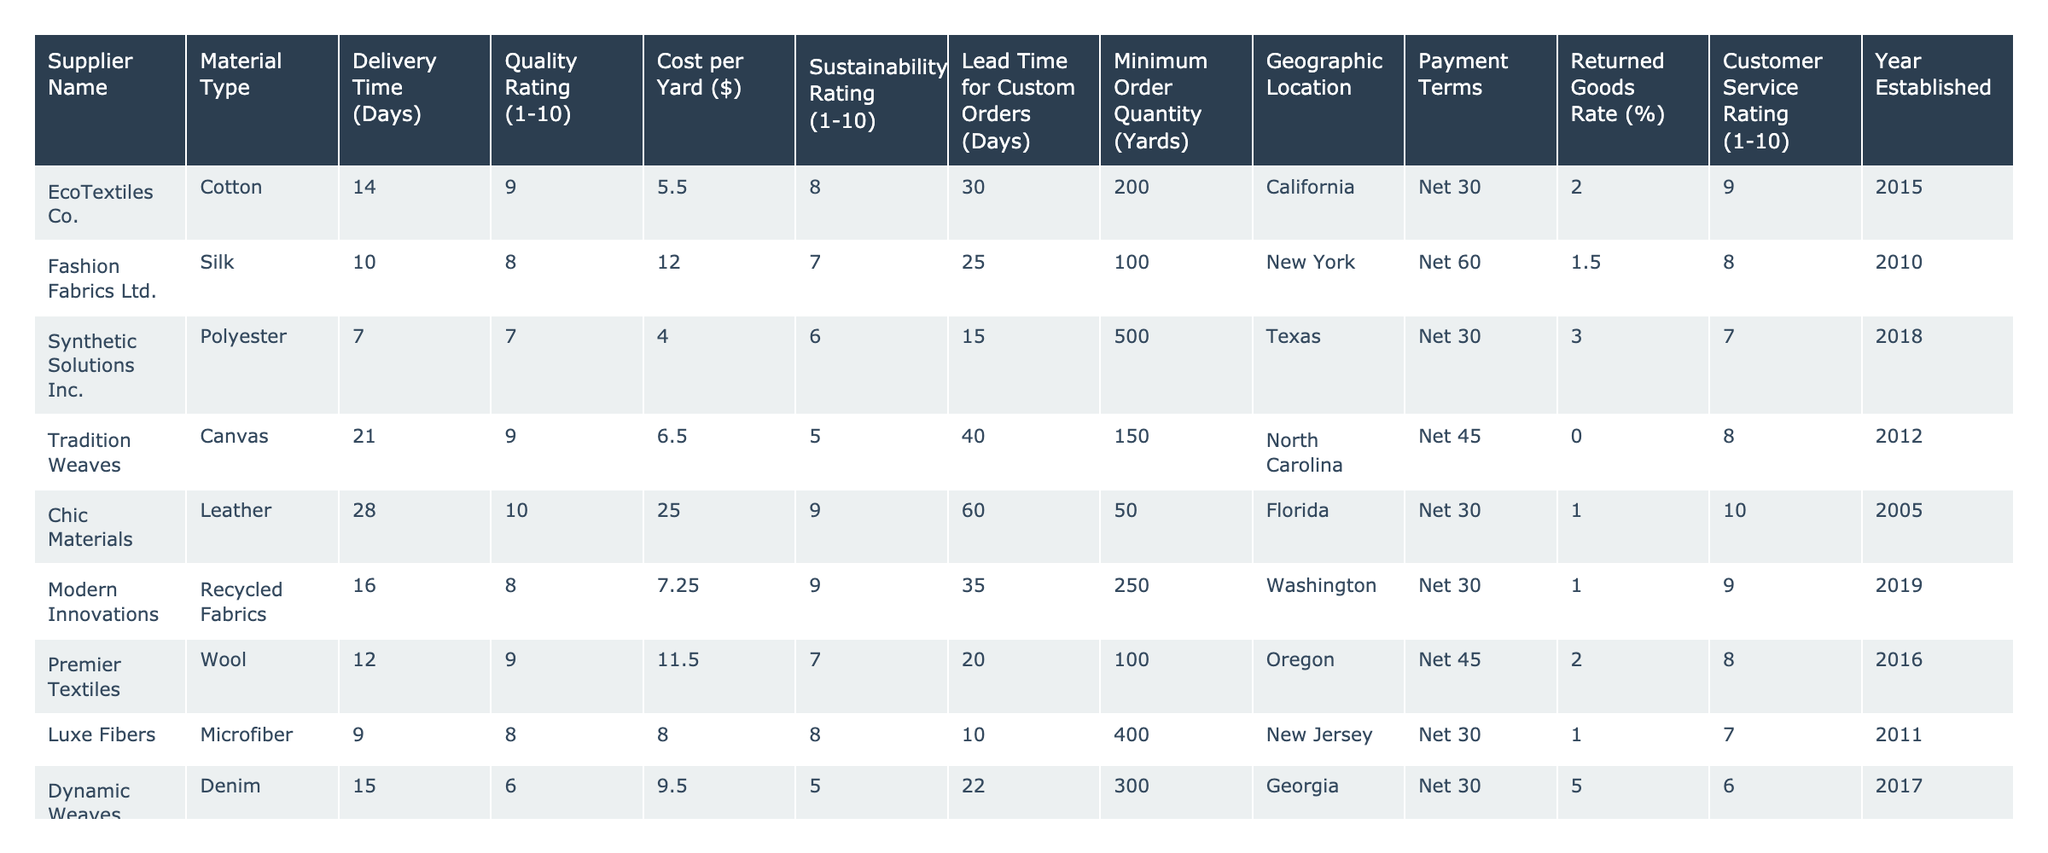What is the quality rating of EcoTextiles Co.'s materials? The table shows that EcoTextiles Co. has a quality rating of 9 out of 10.
Answer: 9 How many days does it take Synthetic Solutions Inc. to deliver their polyester materials? According to the table, Synthetic Solutions Inc. has a delivery time of 7 days for their polyester materials.
Answer: 7 Which supplier has the highest sustainability rating? By reviewing the sustainability ratings, Sustainable Fabrics Inc. has the highest rating of 10 out of 10.
Answer: 10 What is the cost per yard of Chic Materials' leather? The table lists the cost per yard of Chic Materials' leather as $25.00.
Answer: $25.00 How many suppliers have a lead time for custom orders of less than 30 days? From the table, Luxe Fibers and Dynamic Weaves have lead times of 10 and 22 days respectively, totaling 2 suppliers with less than 30 days lead time.
Answer: 2 What is the average delivery time among all suppliers? The average delivery time can be calculated as (14 + 10 + 7 + 21 + 28 + 16 + 12 + 9 + 15 + 18) = 180, and there are 10 suppliers, so the average delivery time is 180/10 = 18 days.
Answer: 18 Did any suppliers report a returned goods rate of 0%? Yes, both Sustainable Fabrics Inc. and Tradition Weaves reported a returned goods rate of 0%.
Answer: Yes Which material type has the longest delivery time? Analyzing the delivery times, Chic Materials with leather has the longest delivery time at 28 days.
Answer: 28 days What is the minimum order quantity for Sustainable Fabrics Inc.? The minimum order quantity listed for Sustainable Fabrics Inc. is 150 yards.
Answer: 150 yards What is the average quality rating of suppliers located in New York? Fashion Fabrics Ltd. is the only supplier from New York and has a quality rating of 8, so the average is 8.
Answer: 8 Which material type has the lowest cost per yard? The lowest cost per yard is $4.00 for polyester supplied by Synthetic Solutions Inc.
Answer: $4.00 How many suppliers have a customer service rating of 9 or higher? The suppliers with customer service ratings of 9 or higher are EcoTextiles Co., Chic Materials, Sustainable Fabrics Inc., and Modern Innovations, totaling 4 suppliers.
Answer: 4 What is the difference in cost per yard between the most and least expensive materials? The highest cost per yard is $25.00 for leather and the lowest is $4.00 for polyester, so the difference is $25.00 - $4.00 = $21.00.
Answer: $21.00 Which supplier has the best overall score in terms of quality rating and sustainability rating combined? Evaluating the total scores: EcoTextiles Co. (9+8), Chic Materials (10+9), Sustainable Fabrics Inc. (9+10), giving Sustainable Fabrics Inc. the best with a total of 19.
Answer: Sustainable Fabrics Inc Is there a supplier established before 2010 with a customer service rating of 9 or higher? Yes, EcoTextiles Co. was established in 2015 and has a customer service rating of 9.
Answer: Yes 